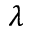<formula> <loc_0><loc_0><loc_500><loc_500>\lambda</formula> 